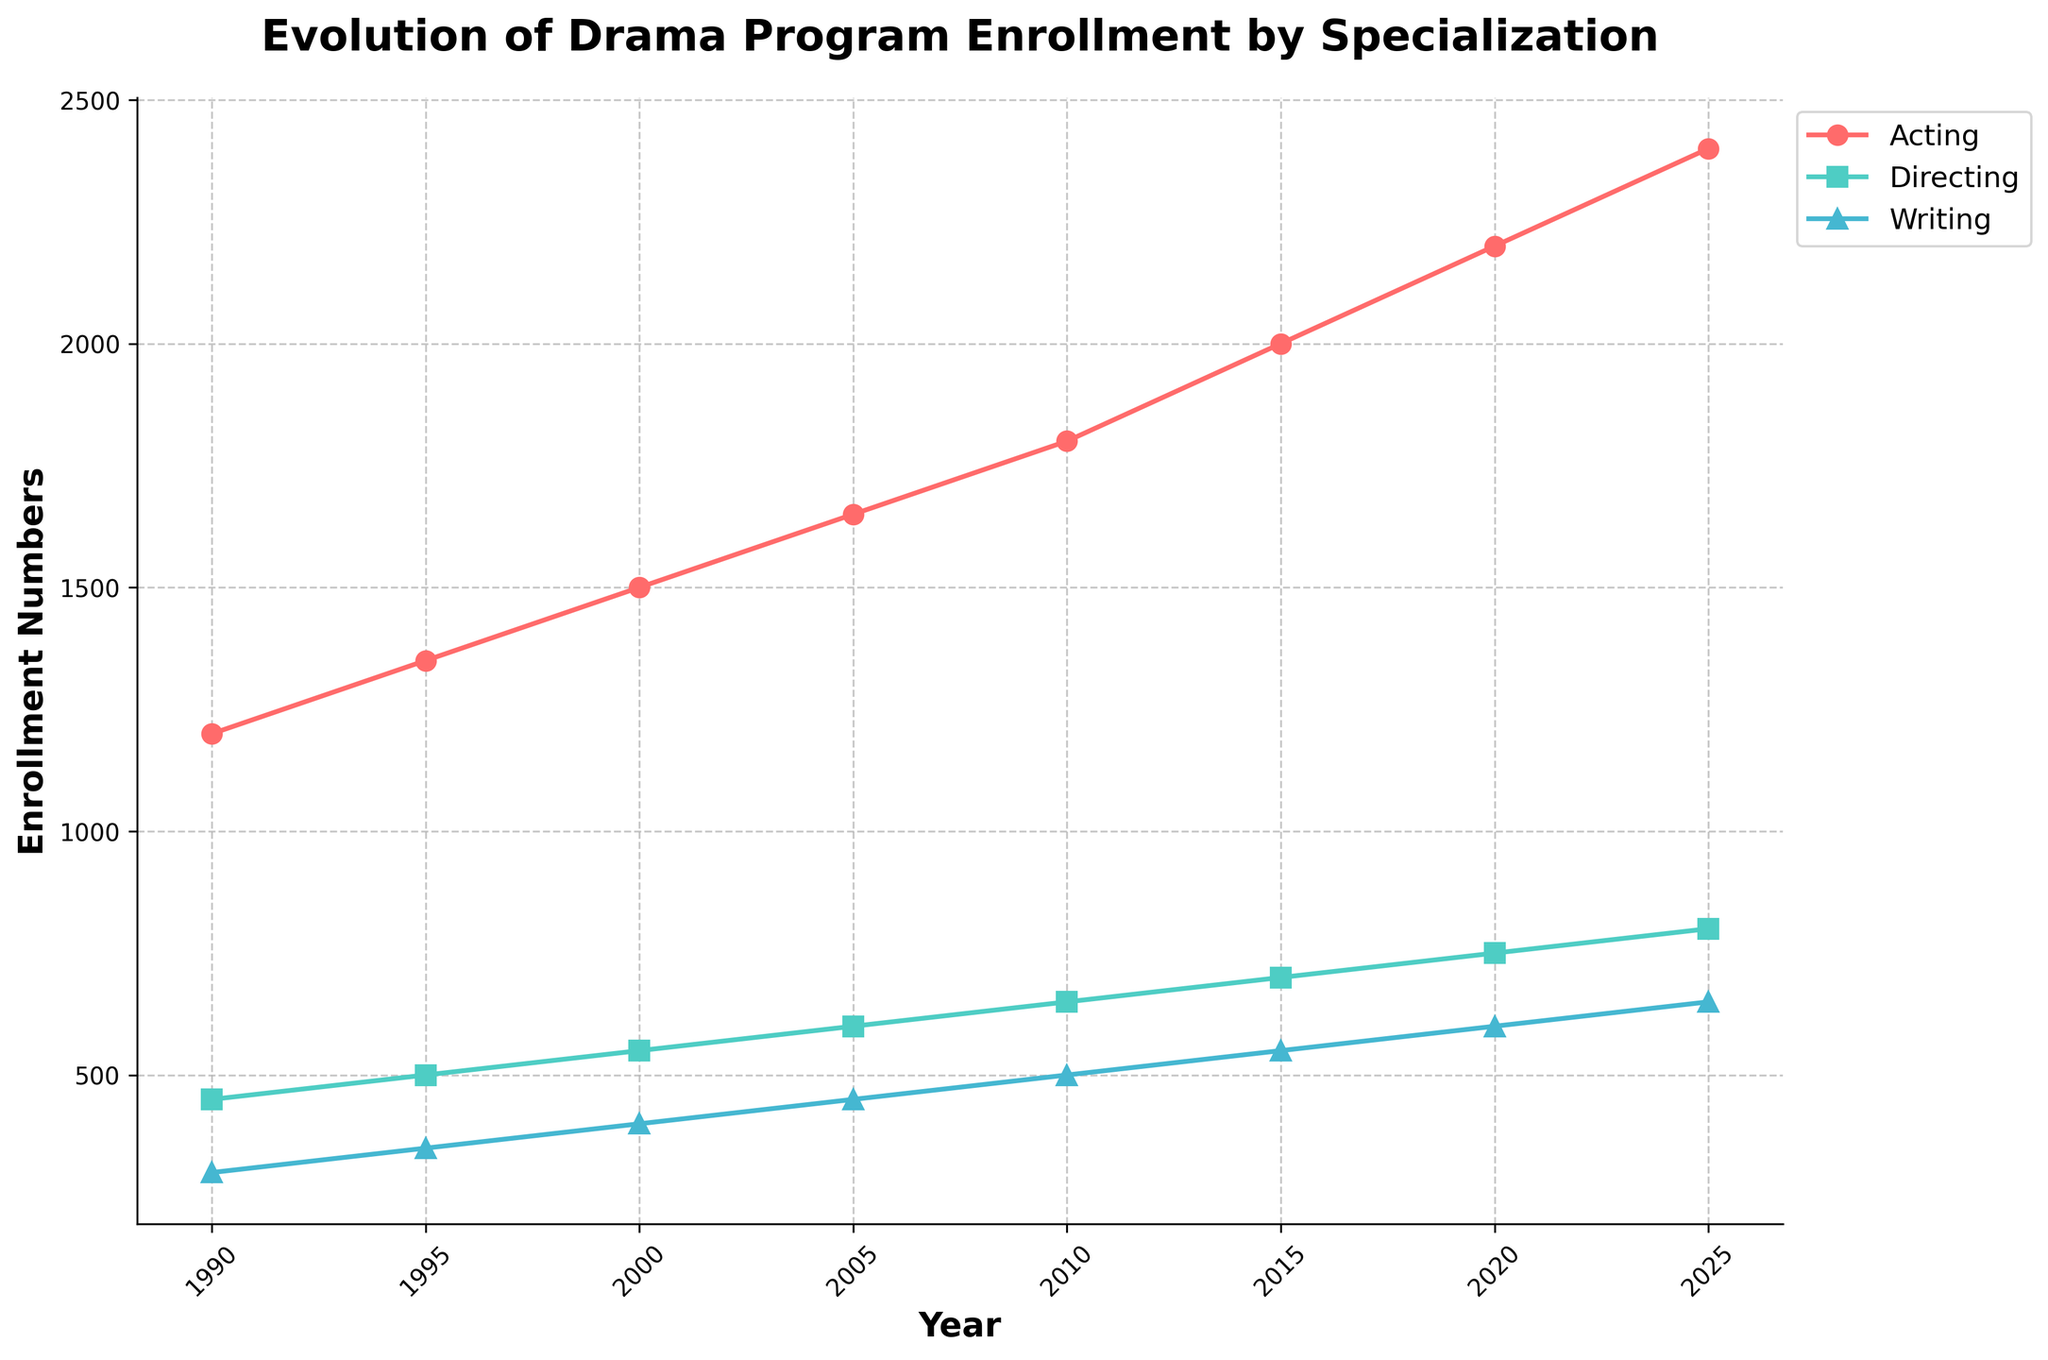What's the overall trend in drama program enrollment for the acting specialization from 1990 to 2025? The line representing acting specialization enrollment on the plot shows a consistently upward trend from 1990 to 2025, indicating a steady increase in the number of students enrolling in acting programs over time.
Answer: Steadily increasing Which specialization has the highest enrollment numbers in 2025? Looking at the endpoints on the line chart, we can see that the line representing acting specialization is the highest in 2025, indicating it has the highest enrollment numbers.
Answer: Acting In which year did the writing specialization enrollment first reach 500? By following the writing specialization line on the chart, we see that it reaches 500 in the year 2010.
Answer: 2010 What is the difference in enrollment numbers for directing specialization between 1995 and 2020? Enrollment for directing in 1995 is 500, and in 2020, it is 750. The difference can be calculated as 750 - 500.
Answer: 250 Which specialization shows the fastest growth rate between 1990 and 2025? Comparing the slopes of the lines representing each specialization, the line for acting is the steepest, indicating the fastest growth rate.
Answer: Acting By how much did the enrollment for the acting specialization increase from 2000 to 2005? The enrollment for acting in 2000 is 1500, and in 2005, it is 1650. The increase is 1650 - 1500.
Answer: 150 Which university had the highest increase in drama enrollment from 1990 to 2025? By comparing the lines for each university, NYU Tisch School of the Arts shows the highest increase from 350 in 1990 to 630 in 2025.
Answer: NYU Tisch School of the Arts How do the trends in enrollment for directing and writing specializations compare from 1990 to 2025? Both specializations show an upward trend, but the directing line is consistently higher and both lines show steady growth without any significant dips or anomalies.
Answer: Directing has higher and steady growth What's the combined enrollment of acting and directing specializations in 2015? Enrollment for acting in 2015 is 2000, and for directing, it is 700. Their combined enrollment is 2000 + 700.
Answer: 2700 Which specialization had the smallest increase in enrollment between 2000 and 2025? Looking at the changes from 2000 to 2025, writing increased from 400 to 650, a difference of 250, which is the smallest increase among the three specializations.
Answer: Writing 